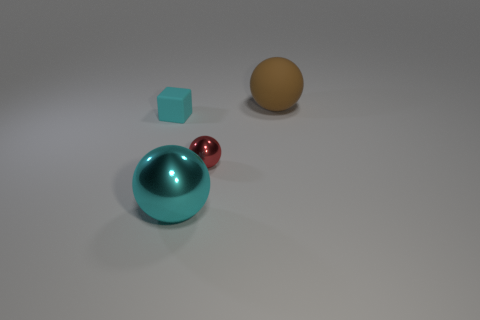What shape is the large thing that is the same color as the tiny block?
Your answer should be very brief. Sphere. What is the size of the thing that is both right of the small cyan rubber thing and left of the small red metallic sphere?
Your answer should be very brief. Large. What number of small blue blocks are there?
Make the answer very short. 0. How many cylinders are brown objects or small red things?
Your response must be concise. 0. How many red metal balls are to the left of the large sphere in front of the big brown object that is behind the large metallic thing?
Keep it short and to the point. 0. The other thing that is the same size as the red thing is what color?
Give a very brief answer. Cyan. What number of other things are there of the same color as the large rubber object?
Provide a short and direct response. 0. Are there more shiny things behind the cyan metal thing than yellow balls?
Make the answer very short. Yes. Is the material of the large brown object the same as the small cube?
Keep it short and to the point. Yes. What number of objects are either matte objects that are on the left side of the brown matte sphere or metal blocks?
Your answer should be very brief. 1. 